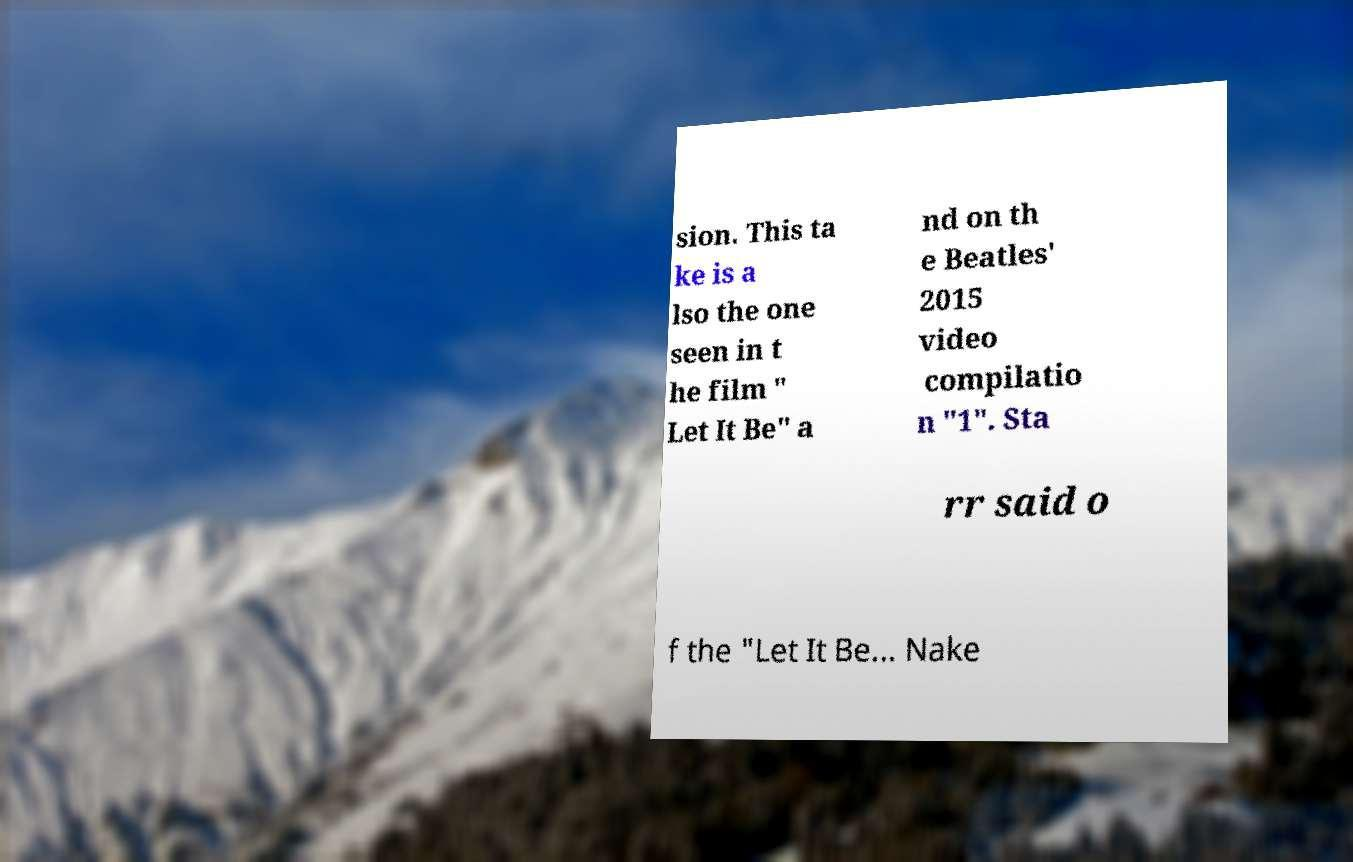Please read and relay the text visible in this image. What does it say? sion. This ta ke is a lso the one seen in t he film " Let It Be" a nd on th e Beatles' 2015 video compilatio n "1". Sta rr said o f the "Let It Be... Nake 